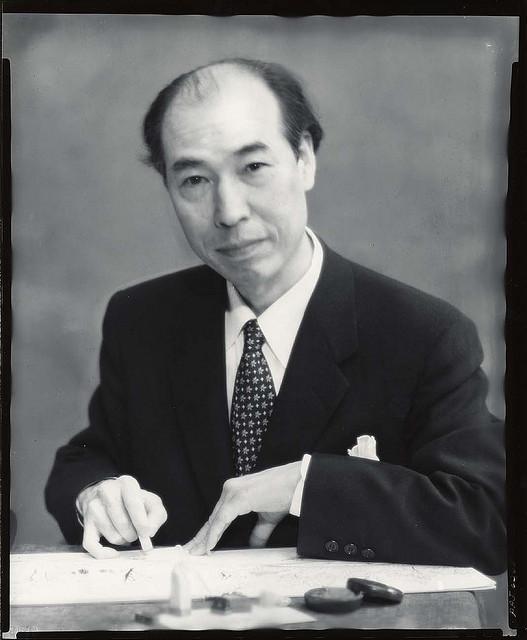How many people are there?
Give a very brief answer. 1. 